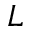<formula> <loc_0><loc_0><loc_500><loc_500>L</formula> 